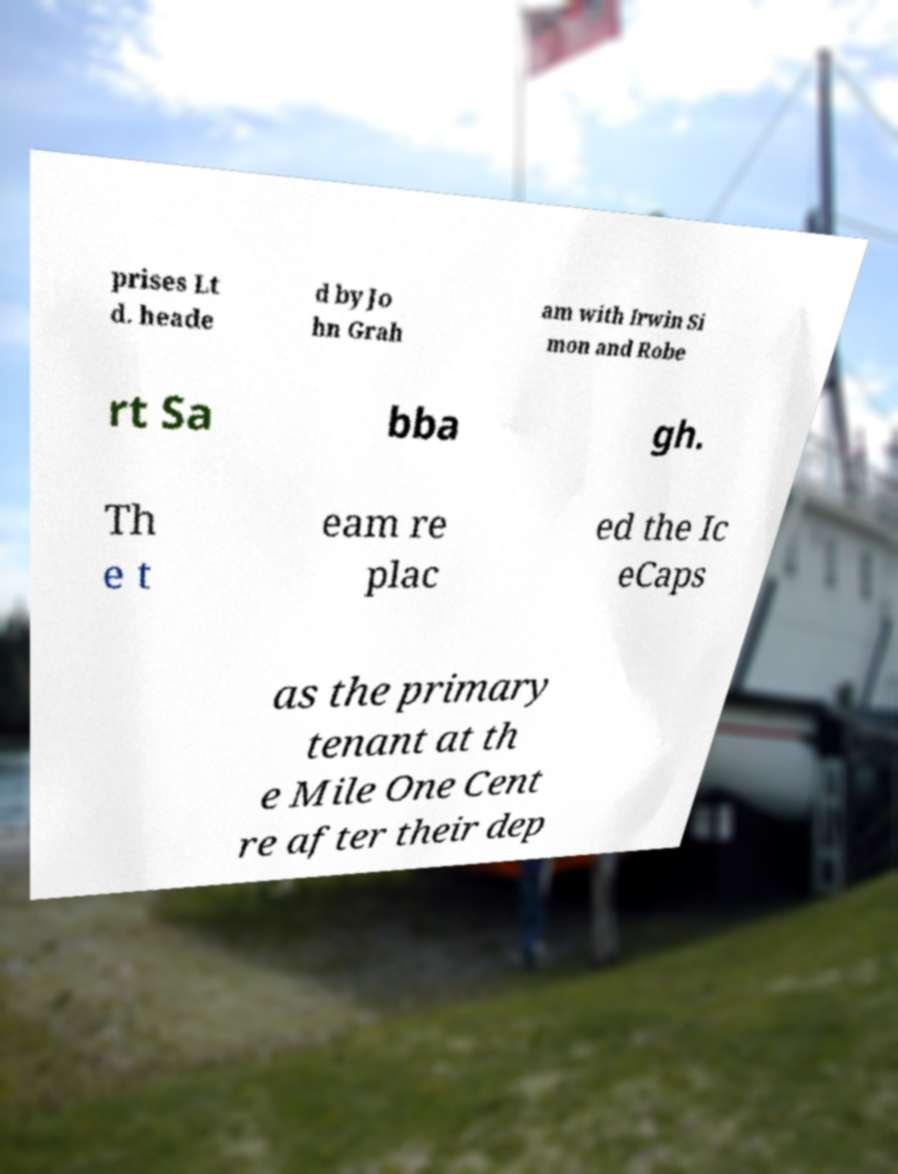What messages or text are displayed in this image? I need them in a readable, typed format. prises Lt d. heade d by Jo hn Grah am with Irwin Si mon and Robe rt Sa bba gh. Th e t eam re plac ed the Ic eCaps as the primary tenant at th e Mile One Cent re after their dep 